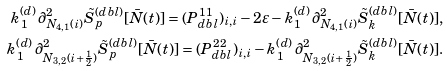<formula> <loc_0><loc_0><loc_500><loc_500>k ^ { ( d ) } _ { 1 } \, \partial ^ { 2 } _ { N _ { 4 , 1 } ( i ) } \tilde { S } ^ { ( d b l ) } _ { p } [ \bar { N } ( t ) ] = ( P _ { d b l } ^ { 1 1 } ) _ { i , i } - 2 \varepsilon - k ^ { ( d ) } _ { 1 } \, \partial ^ { 2 } _ { N _ { 4 , 1 } ( i ) } \tilde { S } ^ { ( d b l ) } _ { k } [ \bar { N } ( t ) ] , \\ k ^ { ( d ) } _ { 1 } \, \partial ^ { 2 } _ { N _ { 3 , 2 } ( i + \frac { 1 } { 2 } ) } \tilde { S } ^ { ( d b l ) } _ { p } [ \bar { N } ( t ) ] = ( P _ { d b l } ^ { 2 2 } ) _ { i , i } - k ^ { ( d ) } _ { 1 } \, \partial ^ { 2 } _ { N _ { 3 , 2 } ( i + \frac { 1 } { 2 } ) } \tilde { S } ^ { ( d b l ) } _ { k } [ \bar { N } ( t ) ] .</formula> 